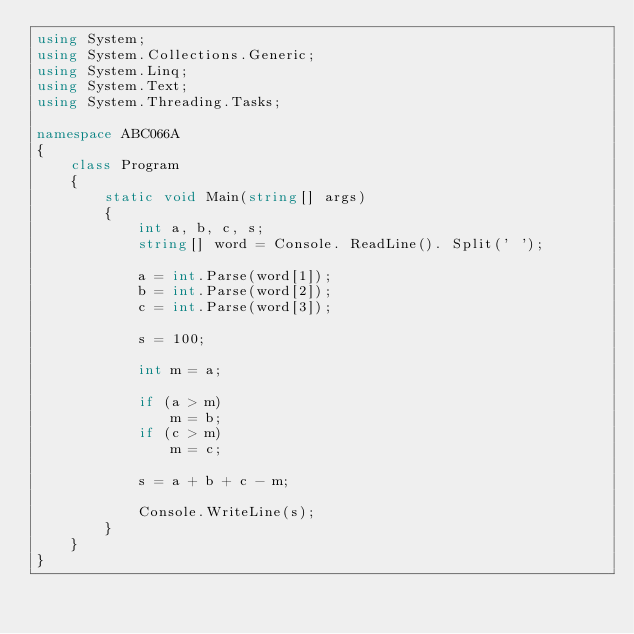Convert code to text. <code><loc_0><loc_0><loc_500><loc_500><_C#_>using System;
using System.Collections.Generic;
using System.Linq;
using System.Text;
using System.Threading.Tasks;

namespace ABC066A
{
	class Program
	{
		static void Main(string[] args)
		{
			int a, b, c, s;
			string[] word = Console. ReadLine(). Split(' ');

			a = int.Parse(word[1]);
			b = int.Parse(word[2]);
			c = int.Parse(word[3]);

			s = 100;

			int m = a;

			if (a > m)
				m = b;
			if (c > m)
				m = c;

			s = a + b + c - m;

			Console.WriteLine(s);
		}
	}
}
</code> 